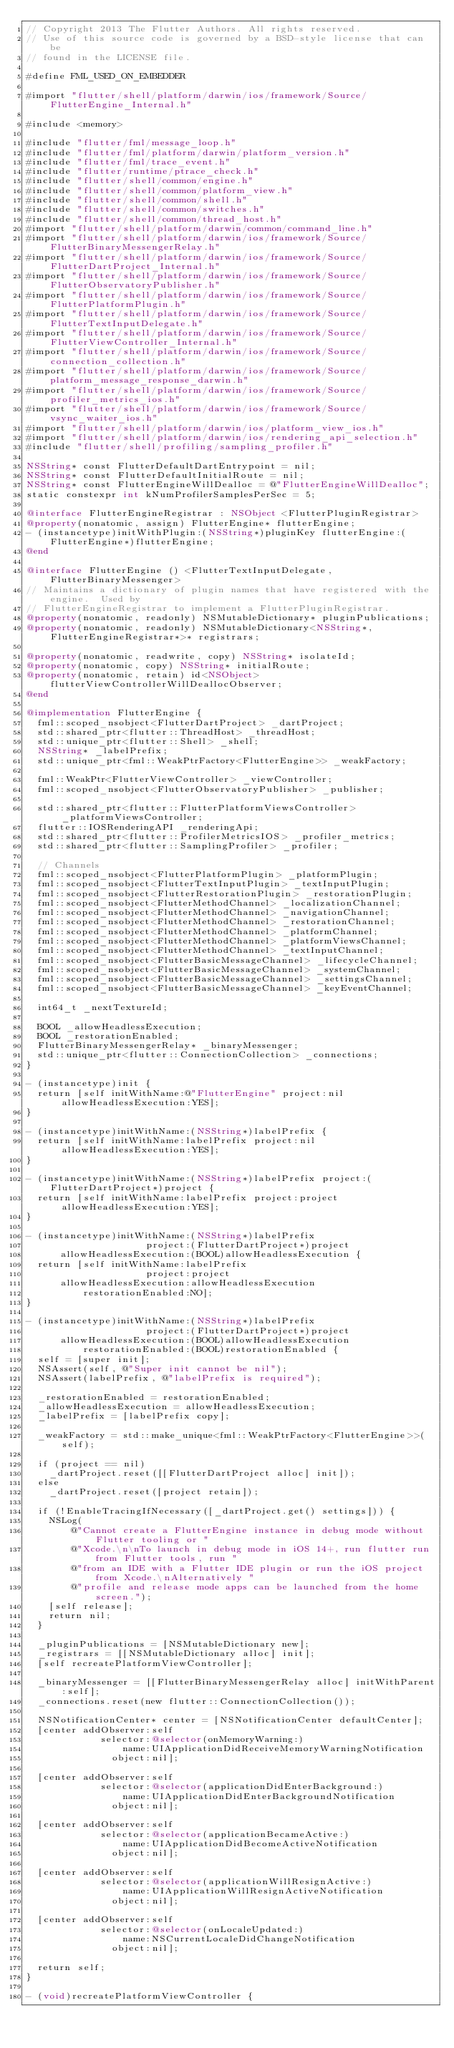<code> <loc_0><loc_0><loc_500><loc_500><_ObjectiveC_>// Copyright 2013 The Flutter Authors. All rights reserved.
// Use of this source code is governed by a BSD-style license that can be
// found in the LICENSE file.

#define FML_USED_ON_EMBEDDER

#import "flutter/shell/platform/darwin/ios/framework/Source/FlutterEngine_Internal.h"

#include <memory>

#include "flutter/fml/message_loop.h"
#include "flutter/fml/platform/darwin/platform_version.h"
#include "flutter/fml/trace_event.h"
#include "flutter/runtime/ptrace_check.h"
#include "flutter/shell/common/engine.h"
#include "flutter/shell/common/platform_view.h"
#include "flutter/shell/common/shell.h"
#include "flutter/shell/common/switches.h"
#include "flutter/shell/common/thread_host.h"
#import "flutter/shell/platform/darwin/common/command_line.h"
#import "flutter/shell/platform/darwin/ios/framework/Source/FlutterBinaryMessengerRelay.h"
#import "flutter/shell/platform/darwin/ios/framework/Source/FlutterDartProject_Internal.h"
#import "flutter/shell/platform/darwin/ios/framework/Source/FlutterObservatoryPublisher.h"
#import "flutter/shell/platform/darwin/ios/framework/Source/FlutterPlatformPlugin.h"
#import "flutter/shell/platform/darwin/ios/framework/Source/FlutterTextInputDelegate.h"
#import "flutter/shell/platform/darwin/ios/framework/Source/FlutterViewController_Internal.h"
#import "flutter/shell/platform/darwin/ios/framework/Source/connection_collection.h"
#import "flutter/shell/platform/darwin/ios/framework/Source/platform_message_response_darwin.h"
#import "flutter/shell/platform/darwin/ios/framework/Source/profiler_metrics_ios.h"
#import "flutter/shell/platform/darwin/ios/framework/Source/vsync_waiter_ios.h"
#import "flutter/shell/platform/darwin/ios/platform_view_ios.h"
#import "flutter/shell/platform/darwin/ios/rendering_api_selection.h"
#include "flutter/shell/profiling/sampling_profiler.h"

NSString* const FlutterDefaultDartEntrypoint = nil;
NSString* const FlutterDefaultInitialRoute = nil;
NSString* const FlutterEngineWillDealloc = @"FlutterEngineWillDealloc";
static constexpr int kNumProfilerSamplesPerSec = 5;

@interface FlutterEngineRegistrar : NSObject <FlutterPluginRegistrar>
@property(nonatomic, assign) FlutterEngine* flutterEngine;
- (instancetype)initWithPlugin:(NSString*)pluginKey flutterEngine:(FlutterEngine*)flutterEngine;
@end

@interface FlutterEngine () <FlutterTextInputDelegate, FlutterBinaryMessenger>
// Maintains a dictionary of plugin names that have registered with the engine.  Used by
// FlutterEngineRegistrar to implement a FlutterPluginRegistrar.
@property(nonatomic, readonly) NSMutableDictionary* pluginPublications;
@property(nonatomic, readonly) NSMutableDictionary<NSString*, FlutterEngineRegistrar*>* registrars;

@property(nonatomic, readwrite, copy) NSString* isolateId;
@property(nonatomic, copy) NSString* initialRoute;
@property(nonatomic, retain) id<NSObject> flutterViewControllerWillDeallocObserver;
@end

@implementation FlutterEngine {
  fml::scoped_nsobject<FlutterDartProject> _dartProject;
  std::shared_ptr<flutter::ThreadHost> _threadHost;
  std::unique_ptr<flutter::Shell> _shell;
  NSString* _labelPrefix;
  std::unique_ptr<fml::WeakPtrFactory<FlutterEngine>> _weakFactory;

  fml::WeakPtr<FlutterViewController> _viewController;
  fml::scoped_nsobject<FlutterObservatoryPublisher> _publisher;

  std::shared_ptr<flutter::FlutterPlatformViewsController> _platformViewsController;
  flutter::IOSRenderingAPI _renderingApi;
  std::shared_ptr<flutter::ProfilerMetricsIOS> _profiler_metrics;
  std::shared_ptr<flutter::SamplingProfiler> _profiler;

  // Channels
  fml::scoped_nsobject<FlutterPlatformPlugin> _platformPlugin;
  fml::scoped_nsobject<FlutterTextInputPlugin> _textInputPlugin;
  fml::scoped_nsobject<FlutterRestorationPlugin> _restorationPlugin;
  fml::scoped_nsobject<FlutterMethodChannel> _localizationChannel;
  fml::scoped_nsobject<FlutterMethodChannel> _navigationChannel;
  fml::scoped_nsobject<FlutterMethodChannel> _restorationChannel;
  fml::scoped_nsobject<FlutterMethodChannel> _platformChannel;
  fml::scoped_nsobject<FlutterMethodChannel> _platformViewsChannel;
  fml::scoped_nsobject<FlutterMethodChannel> _textInputChannel;
  fml::scoped_nsobject<FlutterBasicMessageChannel> _lifecycleChannel;
  fml::scoped_nsobject<FlutterBasicMessageChannel> _systemChannel;
  fml::scoped_nsobject<FlutterBasicMessageChannel> _settingsChannel;
  fml::scoped_nsobject<FlutterBasicMessageChannel> _keyEventChannel;

  int64_t _nextTextureId;

  BOOL _allowHeadlessExecution;
  BOOL _restorationEnabled;
  FlutterBinaryMessengerRelay* _binaryMessenger;
  std::unique_ptr<flutter::ConnectionCollection> _connections;
}

- (instancetype)init {
  return [self initWithName:@"FlutterEngine" project:nil allowHeadlessExecution:YES];
}

- (instancetype)initWithName:(NSString*)labelPrefix {
  return [self initWithName:labelPrefix project:nil allowHeadlessExecution:YES];
}

- (instancetype)initWithName:(NSString*)labelPrefix project:(FlutterDartProject*)project {
  return [self initWithName:labelPrefix project:project allowHeadlessExecution:YES];
}

- (instancetype)initWithName:(NSString*)labelPrefix
                     project:(FlutterDartProject*)project
      allowHeadlessExecution:(BOOL)allowHeadlessExecution {
  return [self initWithName:labelPrefix
                     project:project
      allowHeadlessExecution:allowHeadlessExecution
          restorationEnabled:NO];
}

- (instancetype)initWithName:(NSString*)labelPrefix
                     project:(FlutterDartProject*)project
      allowHeadlessExecution:(BOOL)allowHeadlessExecution
          restorationEnabled:(BOOL)restorationEnabled {
  self = [super init];
  NSAssert(self, @"Super init cannot be nil");
  NSAssert(labelPrefix, @"labelPrefix is required");

  _restorationEnabled = restorationEnabled;
  _allowHeadlessExecution = allowHeadlessExecution;
  _labelPrefix = [labelPrefix copy];

  _weakFactory = std::make_unique<fml::WeakPtrFactory<FlutterEngine>>(self);

  if (project == nil)
    _dartProject.reset([[FlutterDartProject alloc] init]);
  else
    _dartProject.reset([project retain]);

  if (!EnableTracingIfNecessary([_dartProject.get() settings])) {
    NSLog(
        @"Cannot create a FlutterEngine instance in debug mode without Flutter tooling or "
        @"Xcode.\n\nTo launch in debug mode in iOS 14+, run flutter run from Flutter tools, run "
        @"from an IDE with a Flutter IDE plugin or run the iOS project from Xcode.\nAlternatively "
        @"profile and release mode apps can be launched from the home screen.");
    [self release];
    return nil;
  }

  _pluginPublications = [NSMutableDictionary new];
  _registrars = [[NSMutableDictionary alloc] init];
  [self recreatePlatformViewController];

  _binaryMessenger = [[FlutterBinaryMessengerRelay alloc] initWithParent:self];
  _connections.reset(new flutter::ConnectionCollection());

  NSNotificationCenter* center = [NSNotificationCenter defaultCenter];
  [center addObserver:self
             selector:@selector(onMemoryWarning:)
                 name:UIApplicationDidReceiveMemoryWarningNotification
               object:nil];

  [center addObserver:self
             selector:@selector(applicationDidEnterBackground:)
                 name:UIApplicationDidEnterBackgroundNotification
               object:nil];

  [center addObserver:self
             selector:@selector(applicationBecameActive:)
                 name:UIApplicationDidBecomeActiveNotification
               object:nil];

  [center addObserver:self
             selector:@selector(applicationWillResignActive:)
                 name:UIApplicationWillResignActiveNotification
               object:nil];

  [center addObserver:self
             selector:@selector(onLocaleUpdated:)
                 name:NSCurrentLocaleDidChangeNotification
               object:nil];

  return self;
}

- (void)recreatePlatformViewController {</code> 